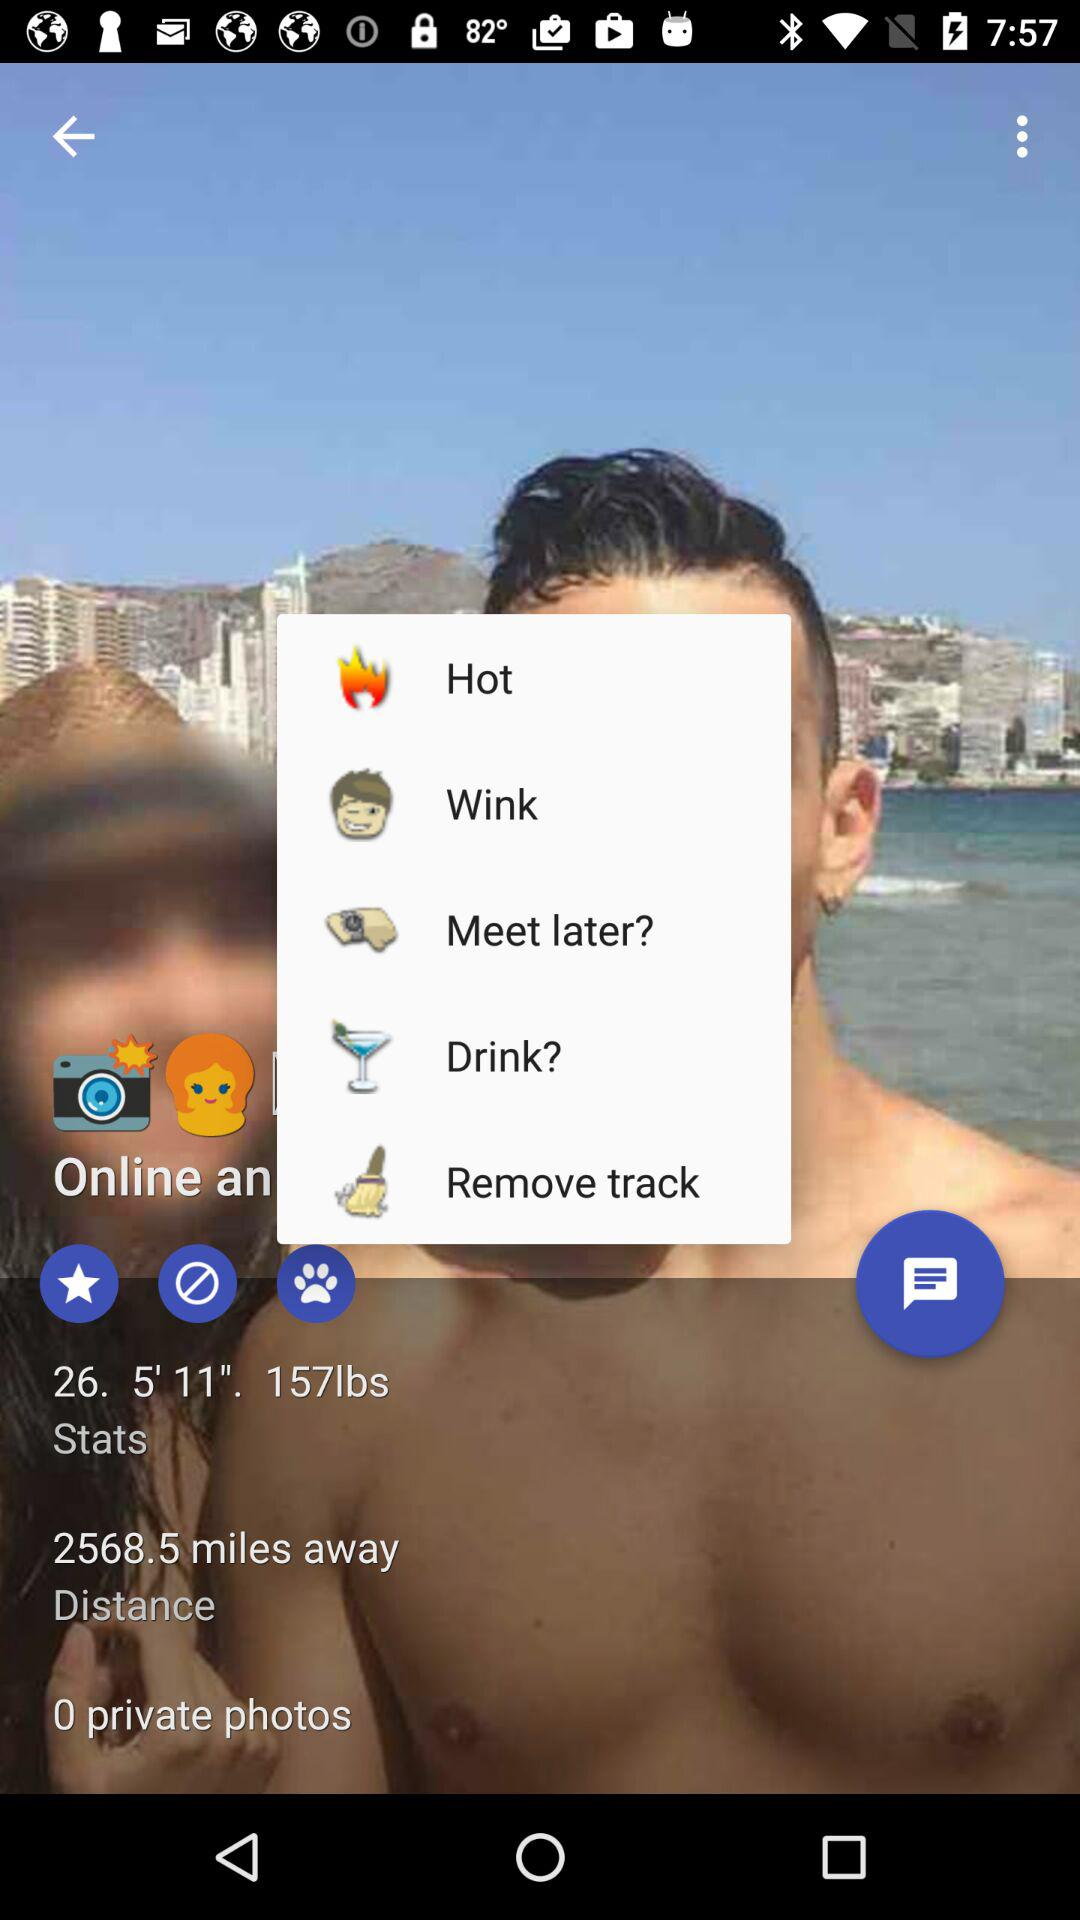Are there any private photos? There are 0 private photos. 